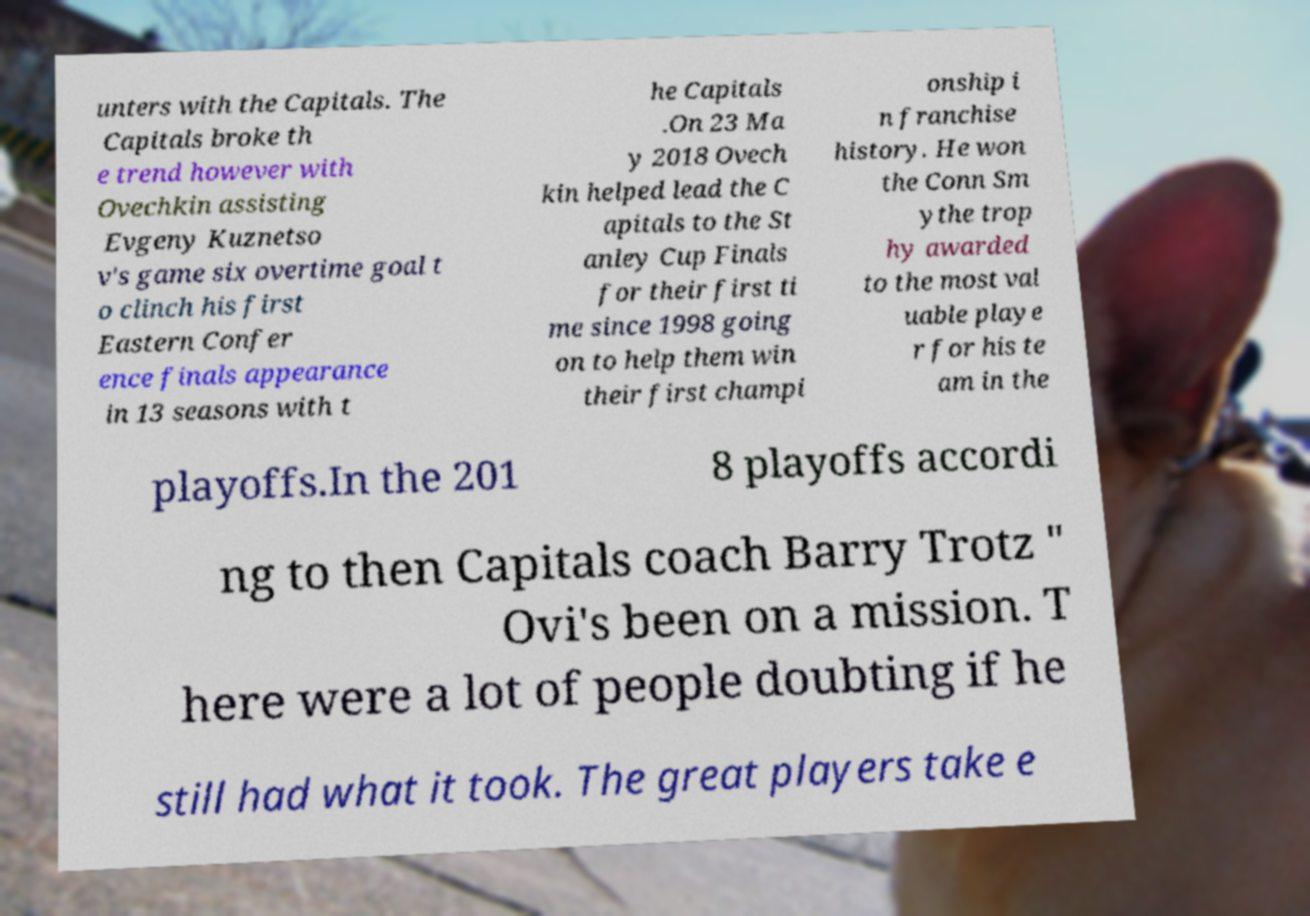For documentation purposes, I need the text within this image transcribed. Could you provide that? unters with the Capitals. The Capitals broke th e trend however with Ovechkin assisting Evgeny Kuznetso v's game six overtime goal t o clinch his first Eastern Confer ence finals appearance in 13 seasons with t he Capitals .On 23 Ma y 2018 Ovech kin helped lead the C apitals to the St anley Cup Finals for their first ti me since 1998 going on to help them win their first champi onship i n franchise history. He won the Conn Sm ythe trop hy awarded to the most val uable playe r for his te am in the playoffs.In the 201 8 playoffs accordi ng to then Capitals coach Barry Trotz " Ovi's been on a mission. T here were a lot of people doubting if he still had what it took. The great players take e 